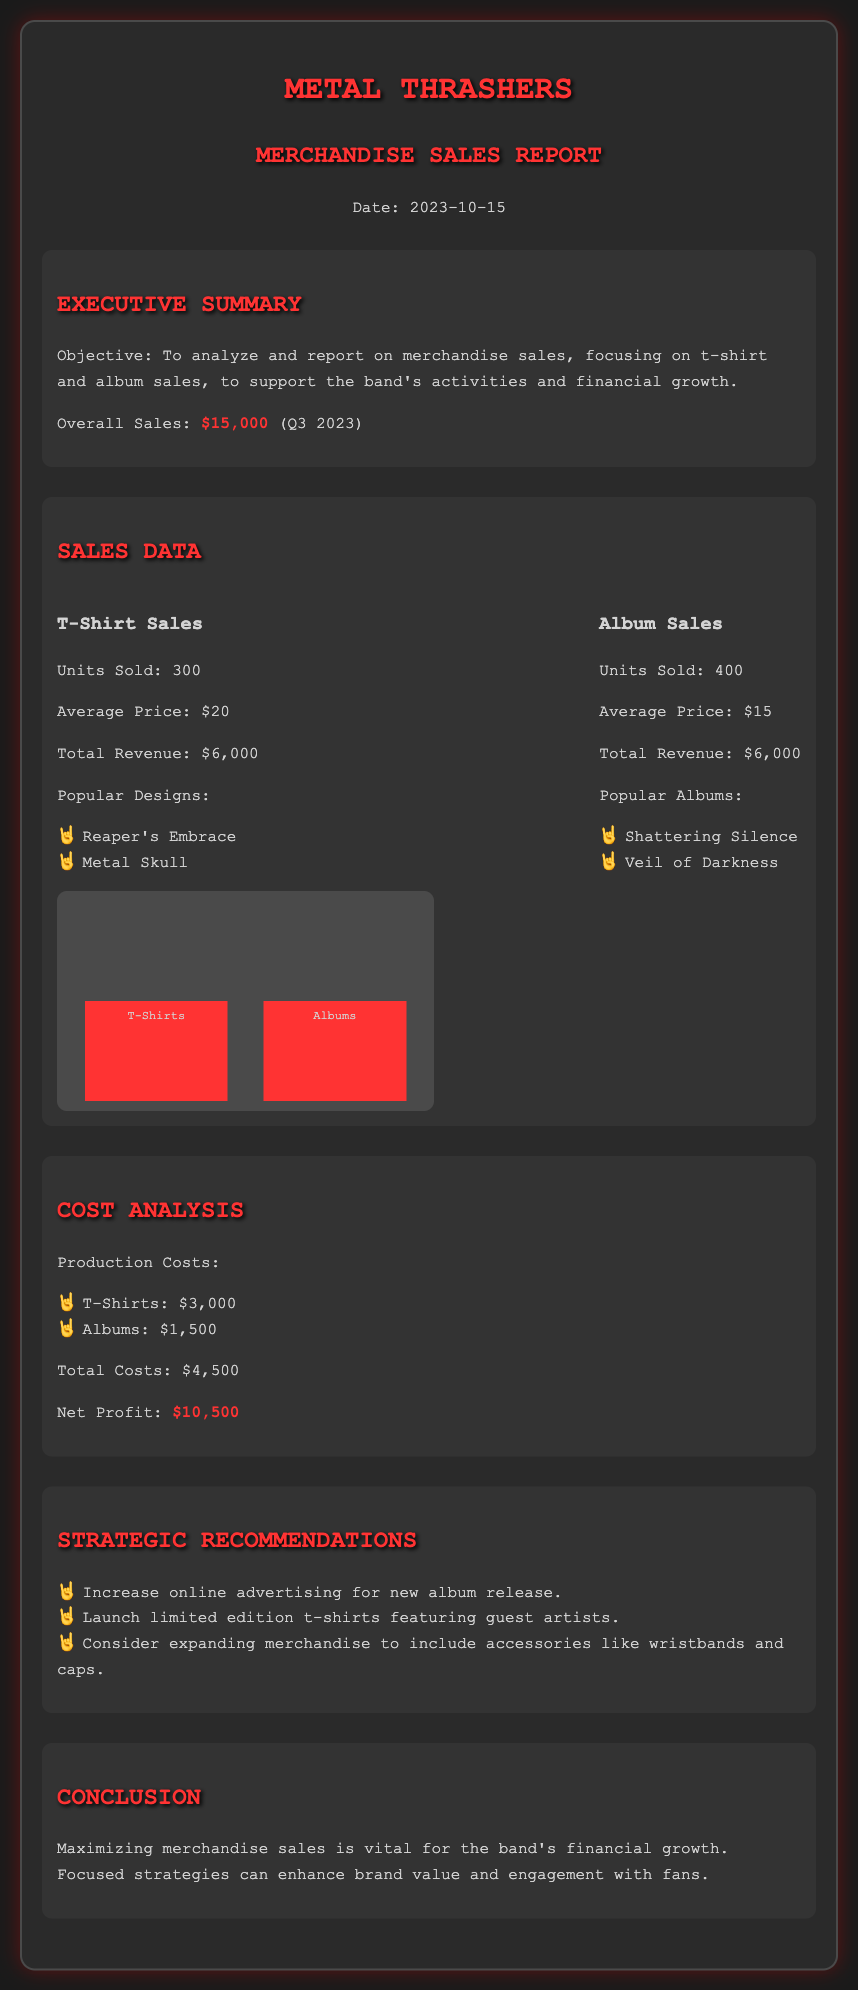What was the overall sales for Q3 2023? The overall sales figure is stated in the executive summary section of the document as the total sales for Q3 2023.
Answer: $15,000 How many t-shirts were sold? The units sold for t-shirts is mentioned under the sales data section, specifically in the t-shirt sales subsection.
Answer: 300 What is the average price of the albums? The average price for albums is provided in the sales data section of the document.
Answer: $15 What were the production costs for t-shirts? The production costs for t-shirts are listed in the cost analysis section, specifically in the production costs subsection.
Answer: $3,000 What is the net profit reported in the document? The net profit is detailed in the cost analysis section, indicating the financial outcome after costs are deducted from revenue.
Answer: $10,500 Which t-shirt designs are popular? The popular t-shirt designs are listed under the t-shirt sales subsection, providing insights into the best-selling designs.
Answer: Reaper's Embrace, Metal Skull What is one of the strategic recommendations? The strategic recommendations section provides a list of suggested actions for improving sales and fan engagement.
Answer: Increase online advertising for new album release How many albums were sold? The units sold for albums is noted in the sales data section of the document, specifically in the album sales subsection.
Answer: 400 What was the total revenue from t-shirt sales? The total revenue for t-shirt sales is explicitly mentioned in the t-shirt sales subsection of the sales data section.
Answer: $6,000 